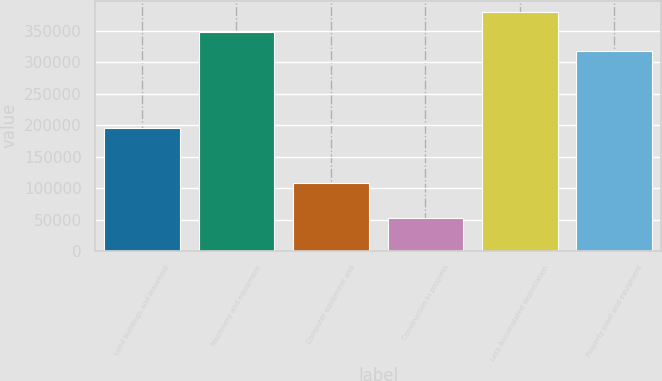Convert chart to OTSL. <chart><loc_0><loc_0><loc_500><loc_500><bar_chart><fcel>Land buildings and leasehold<fcel>Machinery and equipment<fcel>Computer equipment and<fcel>Construction in progress<fcel>Less Accumulated depreciation<fcel>Property plant and equipment<nl><fcel>194923<fcel>348058<fcel>107743<fcel>51834<fcel>378681<fcel>317435<nl></chart> 